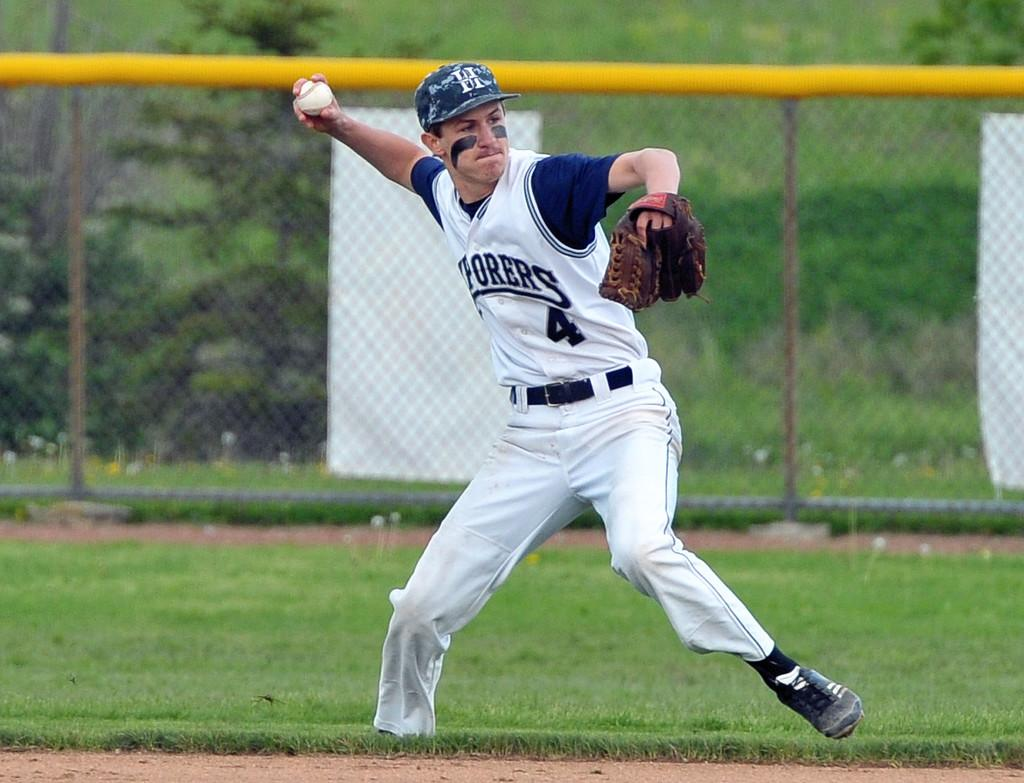<image>
Offer a succinct explanation of the picture presented. a baseball player with the numbere 4 and letter H 